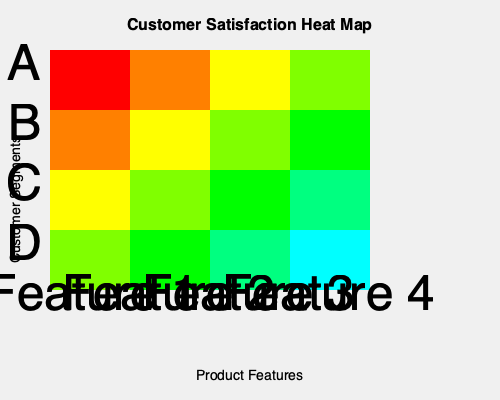Based on the heat map of customer satisfaction ratings for various product features, which feature shows the highest overall satisfaction across all customer segments, and which customer segment appears to be the most satisfied with all features? To answer this question, we need to analyze the heat map systematically:

1. Understand the heat map:
   - Rows represent customer segments (A, B, C, D)
   - Columns represent product features (1, 2, 3, 4)
   - Colors indicate satisfaction levels (red: lowest, cyan: highest)

2. Analyze features (columns):
   - Feature 1: Mostly red and orange (low satisfaction)
   - Feature 2: Mostly orange and yellow (medium-low satisfaction)
   - Feature 3: Mostly yellow and light green (medium-high satisfaction)
   - Feature 4: Mostly light green and cyan (highest satisfaction)

3. Identify the feature with highest overall satisfaction:
   Feature 4 has the most green and cyan cells, indicating the highest overall satisfaction across all segments.

4. Analyze customer segments (rows):
   - Segment A: Mostly red and orange (lowest satisfaction)
   - Segment B: Mostly orange and yellow (medium-low satisfaction)
   - Segment C: Mostly yellow and light green (medium-high satisfaction)
   - Segment D: Mostly light green and cyan (highest satisfaction)

5. Identify the most satisfied customer segment:
   Segment D has the most green and cyan cells, indicating the highest overall satisfaction across all features.
Answer: Feature 4; Segment D 